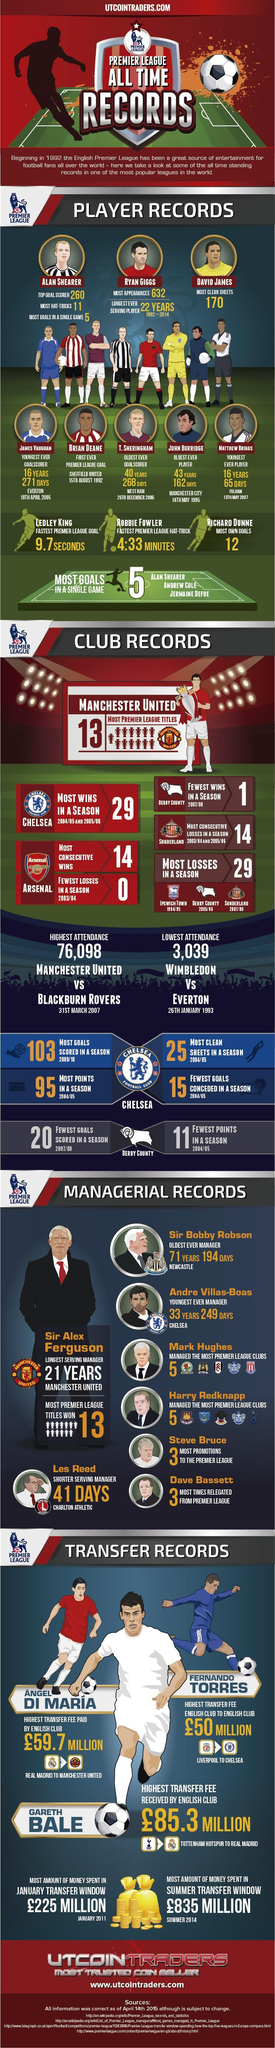WHo is the youngest every player
Answer the question with a short phrase. Matthew Briggs Who is the oldest every plaer John Burridge What are the club records held by Arsenal Most Consecutive Wins, Fewest Losses in a Season 2003/04 When did Brian Deane score the first ever premier league goal 15th August 1992 premier league is for foot ball or basket ball foot ball What are the top records for Alan Shearer top goal scorer 260, most hat-tricks 11, most goals in a single game 5 Which team did the longest serving manager belong to Manchester United How soon was the fastest premier league goal scored 9.7 seconds What all have scored the most goals in the single game Alan Shearer, Andrew Cole, Jermaine Defoe 